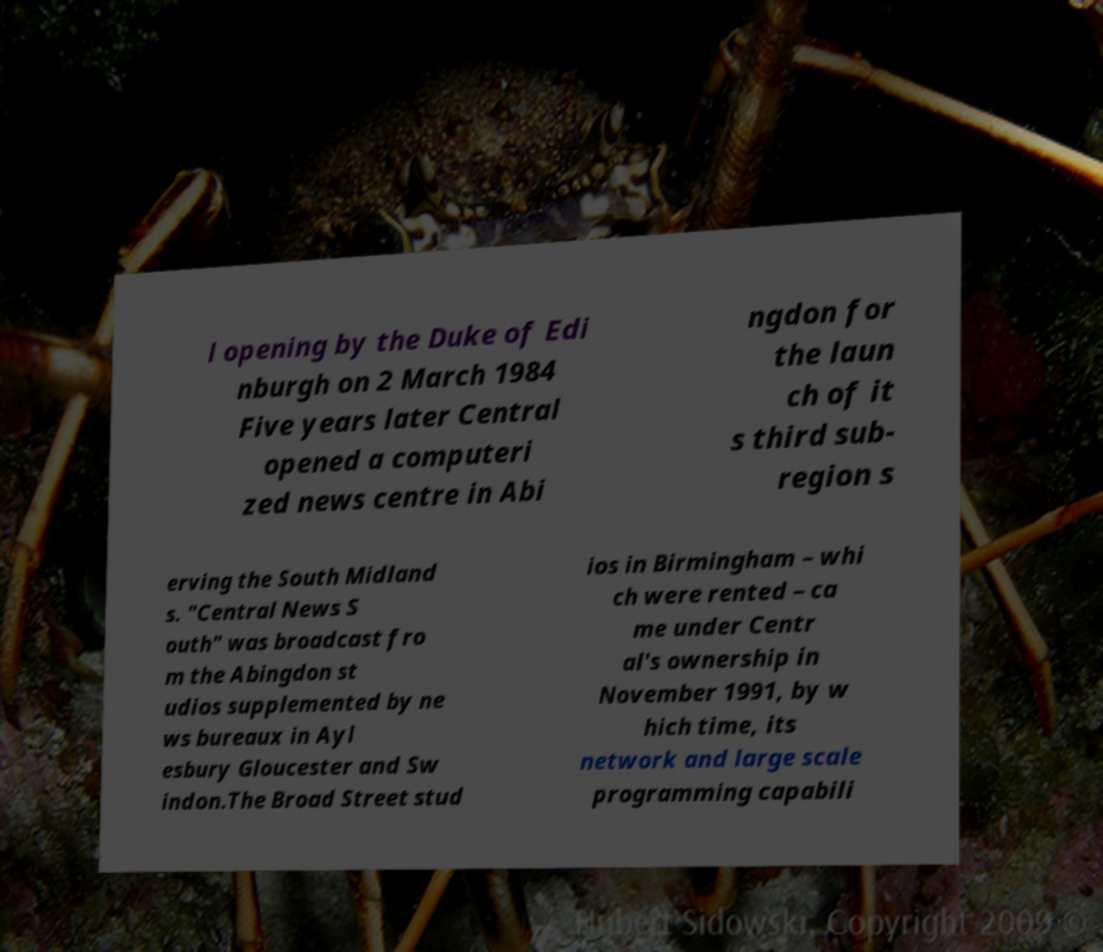Please identify and transcribe the text found in this image. l opening by the Duke of Edi nburgh on 2 March 1984 Five years later Central opened a computeri zed news centre in Abi ngdon for the laun ch of it s third sub- region s erving the South Midland s. "Central News S outh" was broadcast fro m the Abingdon st udios supplemented by ne ws bureaux in Ayl esbury Gloucester and Sw indon.The Broad Street stud ios in Birmingham – whi ch were rented – ca me under Centr al's ownership in November 1991, by w hich time, its network and large scale programming capabili 